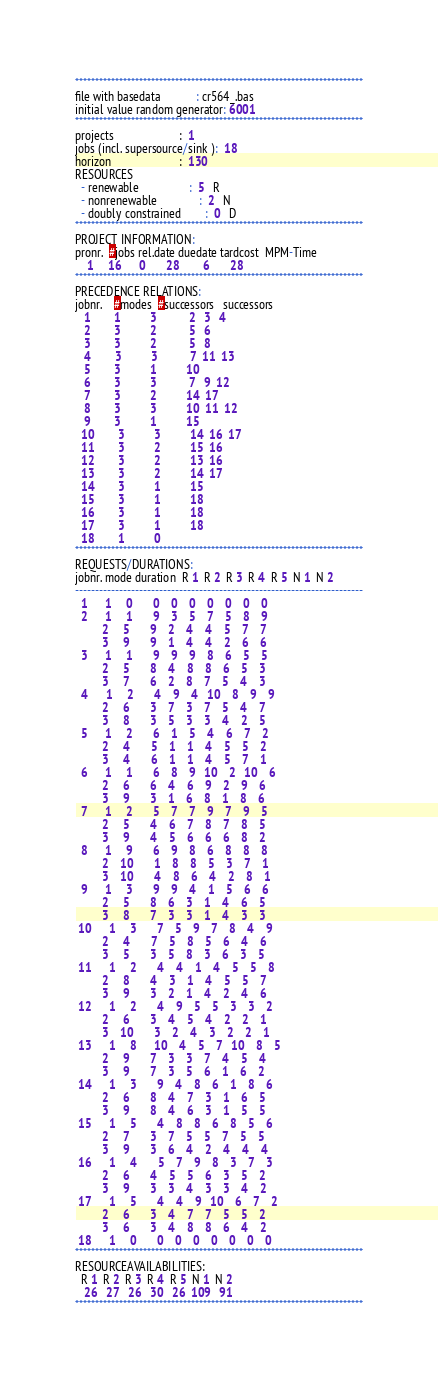Convert code to text. <code><loc_0><loc_0><loc_500><loc_500><_ObjectiveC_>************************************************************************
file with basedata            : cr564_.bas
initial value random generator: 6001
************************************************************************
projects                      :  1
jobs (incl. supersource/sink ):  18
horizon                       :  130
RESOURCES
  - renewable                 :  5   R
  - nonrenewable              :  2   N
  - doubly constrained        :  0   D
************************************************************************
PROJECT INFORMATION:
pronr.  #jobs rel.date duedate tardcost  MPM-Time
    1     16      0       28        6       28
************************************************************************
PRECEDENCE RELATIONS:
jobnr.    #modes  #successors   successors
   1        1          3           2   3   4
   2        3          2           5   6
   3        3          2           5   8
   4        3          3           7  11  13
   5        3          1          10
   6        3          3           7   9  12
   7        3          2          14  17
   8        3          3          10  11  12
   9        3          1          15
  10        3          3          14  16  17
  11        3          2          15  16
  12        3          2          13  16
  13        3          2          14  17
  14        3          1          15
  15        3          1          18
  16        3          1          18
  17        3          1          18
  18        1          0        
************************************************************************
REQUESTS/DURATIONS:
jobnr. mode duration  R 1  R 2  R 3  R 4  R 5  N 1  N 2
------------------------------------------------------------------------
  1      1     0       0    0    0    0    0    0    0
  2      1     1       9    3    5    7    5    8    9
         2     5       9    2    4    4    5    7    7
         3     9       9    1    4    4    2    6    6
  3      1     1       9    9    9    8    6    5    5
         2     5       8    4    8    8    6    5    3
         3     7       6    2    8    7    5    4    3
  4      1     2       4    9    4   10    8    9    9
         2     6       3    7    3    7    5    4    7
         3     8       3    5    3    3    4    2    5
  5      1     2       6    1    5    4    6    7    2
         2     4       5    1    1    4    5    5    2
         3     4       6    1    1    4    5    7    1
  6      1     1       6    8    9   10    2   10    6
         2     6       6    4    6    9    2    9    6
         3     9       3    1    6    8    1    8    6
  7      1     2       5    7    7    9    7    9    5
         2     5       4    6    7    8    7    8    5
         3     9       4    5    6    6    6    8    2
  8      1     9       6    9    8    6    8    8    8
         2    10       1    8    8    5    3    7    1
         3    10       4    8    6    4    2    8    1
  9      1     3       9    9    4    1    5    6    6
         2     5       8    6    3    1    4    6    5
         3     8       7    3    3    1    4    3    3
 10      1     3       7    5    9    7    8    4    9
         2     4       7    5    8    5    6    4    6
         3     5       3    5    8    3    6    3    5
 11      1     2       4    4    1    4    5    5    8
         2     8       4    3    1    4    5    5    7
         3     9       3    2    1    4    2    4    6
 12      1     2       4    9    5    5    3    3    2
         2     6       3    4    5    4    2    2    1
         3    10       3    2    4    3    2    2    1
 13      1     8      10    4    5    7   10    8    5
         2     9       7    3    3    7    4    5    4
         3     9       7    3    5    6    1    6    2
 14      1     3       9    4    8    6    1    8    6
         2     6       8    4    7    3    1    6    5
         3     9       8    4    6    3    1    5    5
 15      1     5       4    8    8    6    8    5    6
         2     7       3    7    5    5    7    5    5
         3     9       3    6    4    2    4    4    4
 16      1     4       5    7    9    8    3    7    3
         2     6       4    5    5    6    3    5    2
         3     9       3    3    4    3    3    4    2
 17      1     5       4    4    9   10    6    7    2
         2     6       3    4    7    7    5    5    2
         3     6       3    4    8    8    6    4    2
 18      1     0       0    0    0    0    0    0    0
************************************************************************
RESOURCEAVAILABILITIES:
  R 1  R 2  R 3  R 4  R 5  N 1  N 2
   26   27   26   30   26  109   91
************************************************************************
</code> 